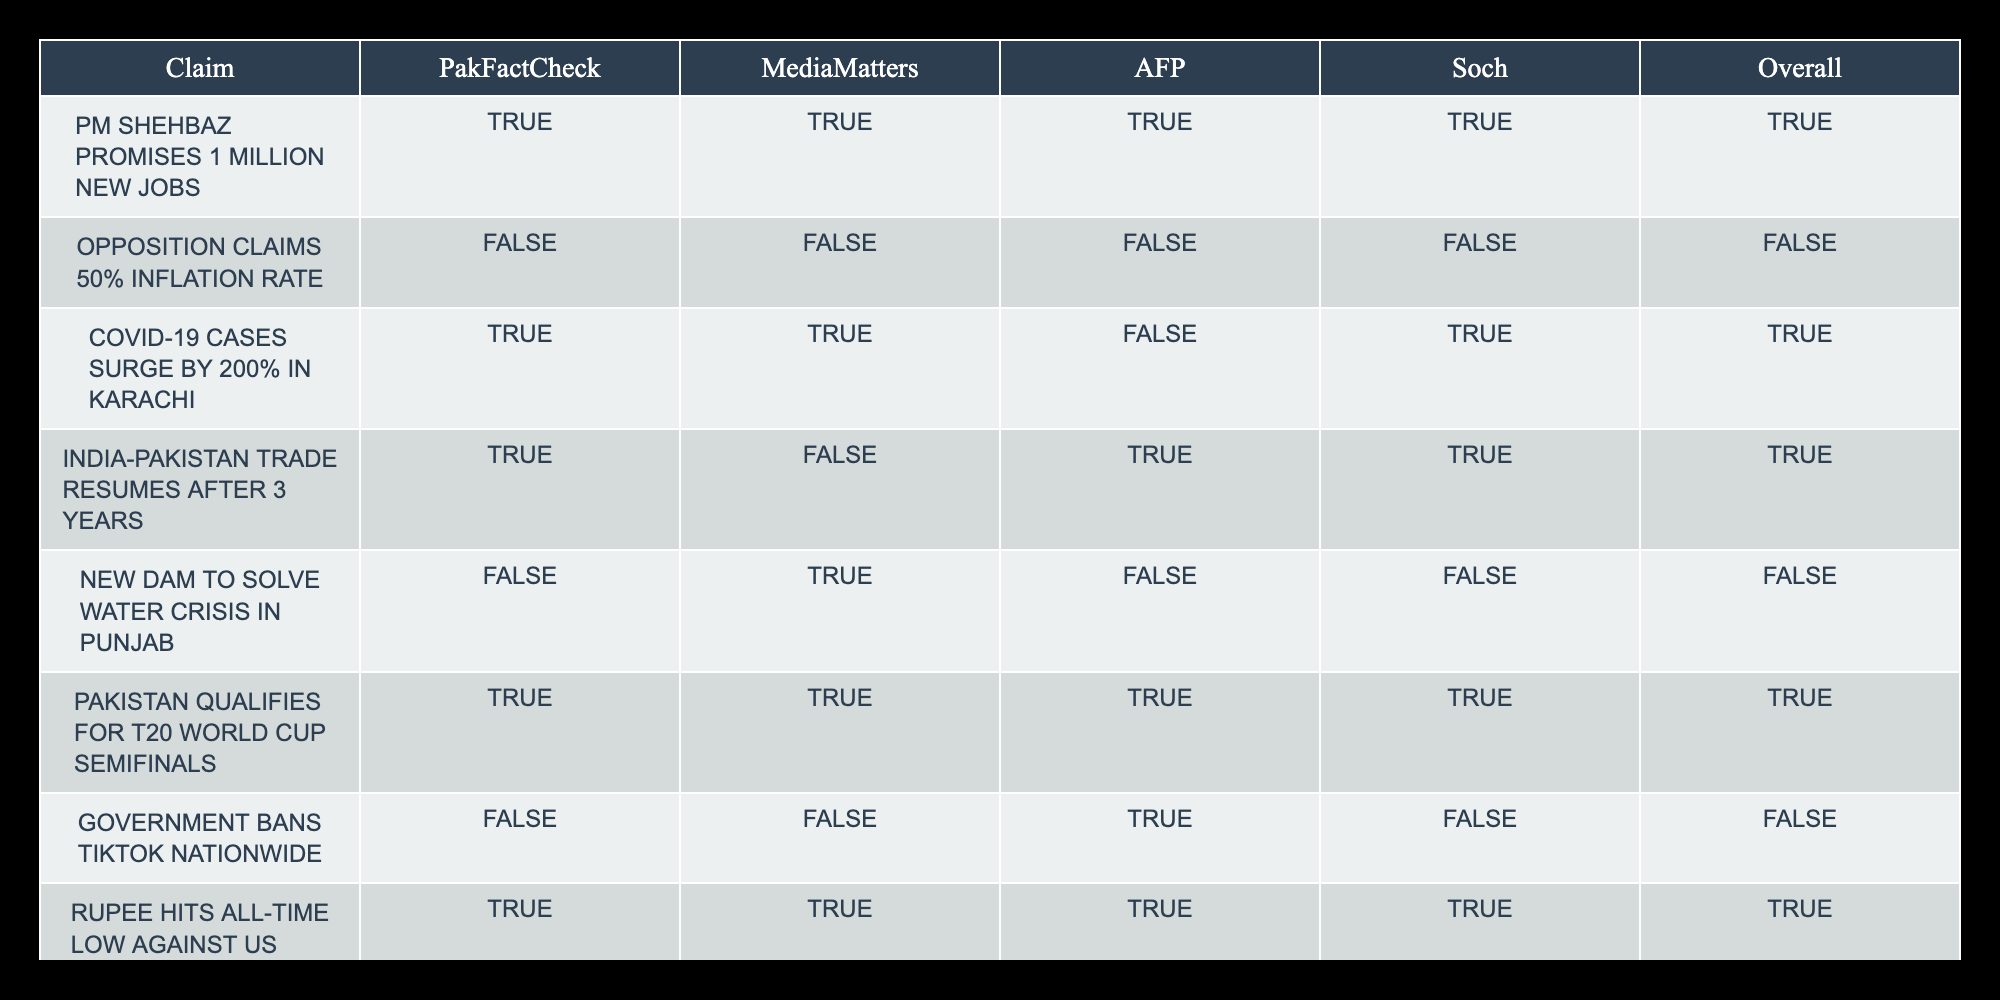What is the overall truth value for the claim "Opposition claims 50% inflation rate"? The overall truth value is found in the last column of the respective row for this claim. The value there is FALSE.
Answer: FALSE How many fact-checking sources confirmed the claim "PM Shehbaz promises 1 million new jobs"? The sources that confirmed this claim include PakFactCheck, MediaMatters, AFP, and Soch, totaling 4.
Answer: 4 What is the truth value for the claim "Government bans TikTok nationwide"? By looking at the row for this claim, the overall truth value is FALSE, as indicated in the last column.
Answer: FALSE How many claims were confirmed by all four fact-checking sources? There are 3 claims that received a TRUE value from all sources; these include: "PM Shehbaz promises 1 million new jobs," "Pakistan qualifies for T20 World Cup semifinals," and "Rupee hits all-time low against US dollar."
Answer: 3 Which claim received mixed responses and was rated TRUE by some sources and FALSE by others? The claim "India-Pakistan trade resumes after 3 years" received responses of TRUE from some sources and FALSE from others such as MediaMatters, indicating varied assessments.
Answer: "India-Pakistan trade resumes after 3 years" What is the average number of TRUE confirmations per claim? Count the number of TRUE responses for each claim: 4, 0, 2, 3, 1, 4, 0, 4, 1, 1. The sum is 20, and there are 10 claims, so the average is 20/10 = 2.
Answer: 2 Is the claim "Free education policy implemented in Sindh" supported by the majority of sources? This claim is confirmed as TRUE by only 2 out of 4 sources. Given that the majority is more than 2, it is not supported by the majority.
Answer: NO What claims have a unanimous agreement among all sources regarding their truth? The claims that received unanimous TRUE results from all sources are "PM Shehbaz promises 1 million new jobs," "Pakistan qualifies for T20 World Cup semifinals," and "Rupee hits all-time low against US dollar."
Answer: 3 claims 